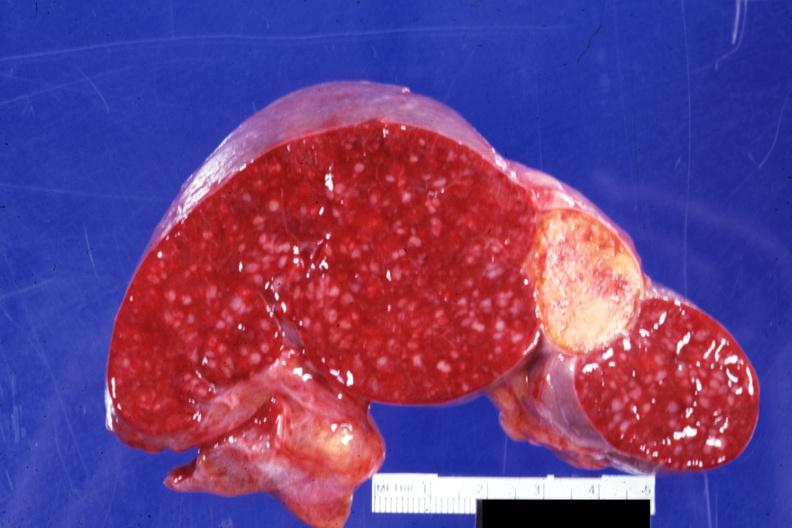s micrognathia triploid fetus present?
Answer the question using a single word or phrase. No 